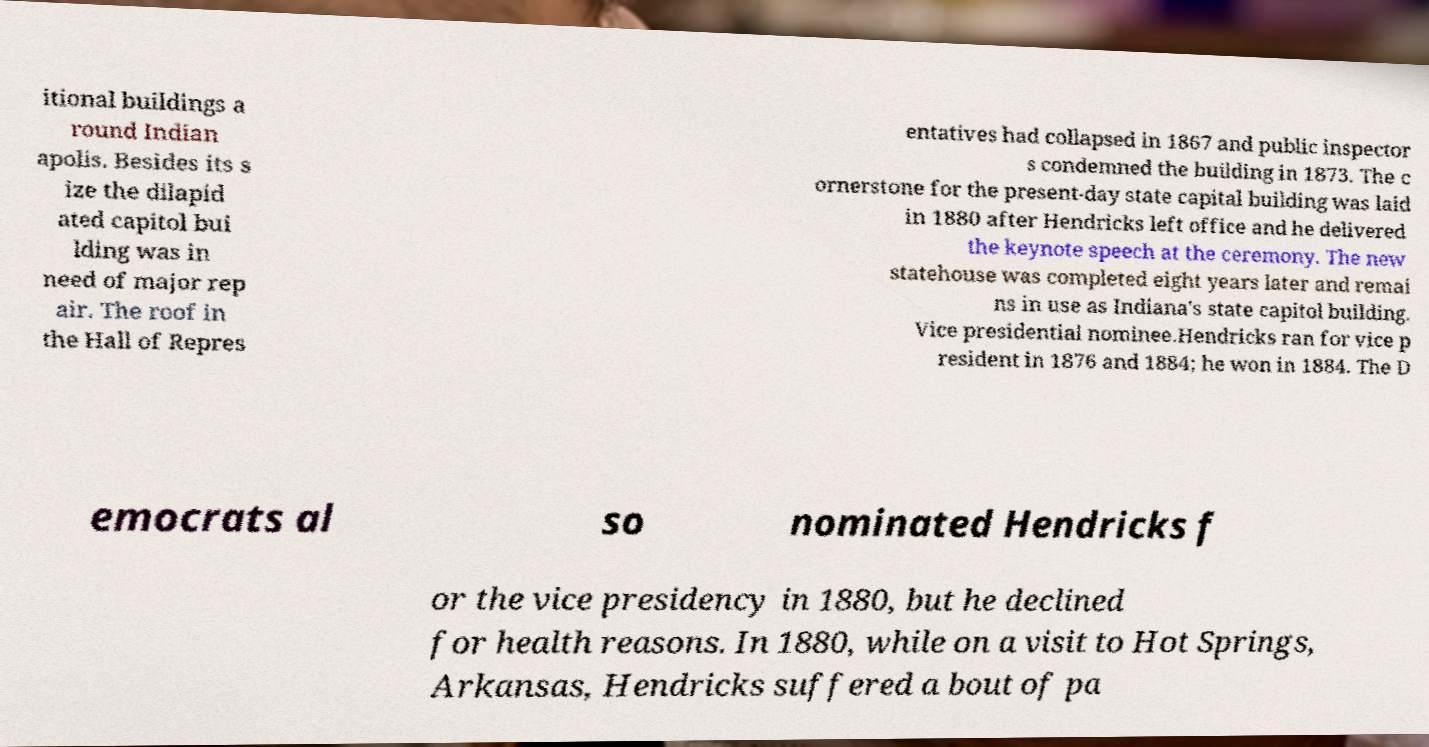Please identify and transcribe the text found in this image. itional buildings a round Indian apolis. Besides its s ize the dilapid ated capitol bui lding was in need of major rep air. The roof in the Hall of Repres entatives had collapsed in 1867 and public inspector s condemned the building in 1873. The c ornerstone for the present-day state capital building was laid in 1880 after Hendricks left office and he delivered the keynote speech at the ceremony. The new statehouse was completed eight years later and remai ns in use as Indiana's state capitol building. Vice presidential nominee.Hendricks ran for vice p resident in 1876 and 1884; he won in 1884. The D emocrats al so nominated Hendricks f or the vice presidency in 1880, but he declined for health reasons. In 1880, while on a visit to Hot Springs, Arkansas, Hendricks suffered a bout of pa 